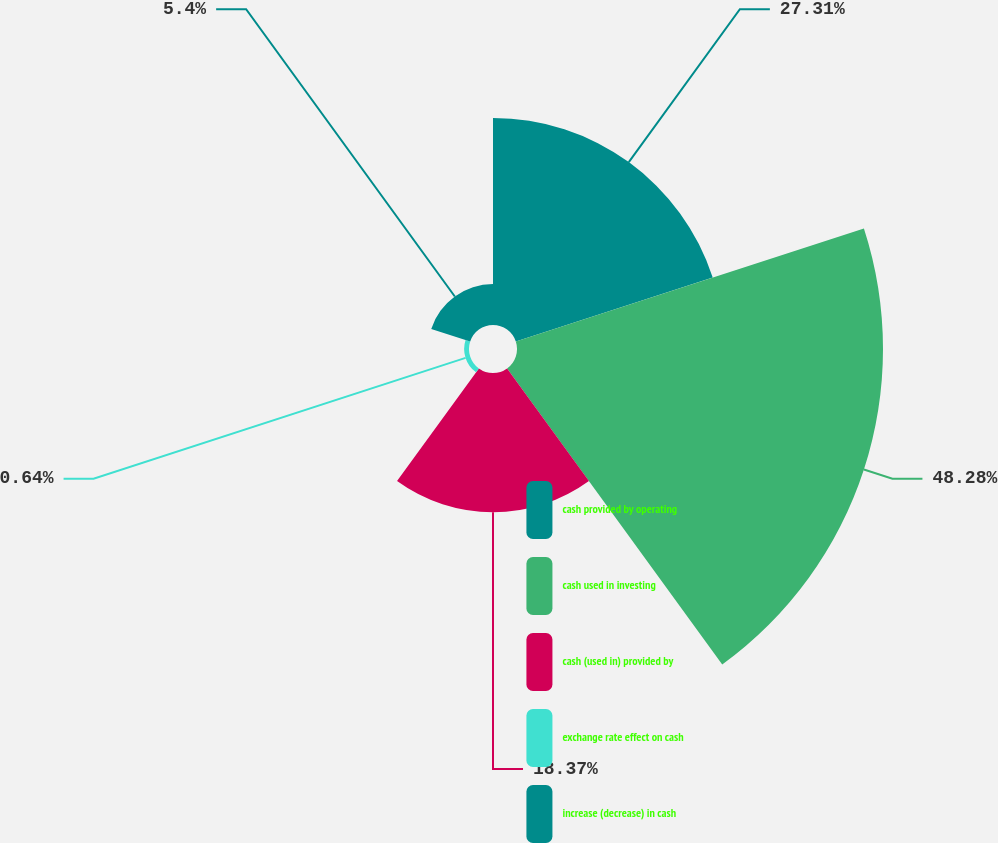Convert chart. <chart><loc_0><loc_0><loc_500><loc_500><pie_chart><fcel>cash provided by operating<fcel>cash used in investing<fcel>cash (used in) provided by<fcel>exchange rate effect on cash<fcel>increase (decrease) in cash<nl><fcel>27.31%<fcel>48.28%<fcel>18.37%<fcel>0.64%<fcel>5.4%<nl></chart> 